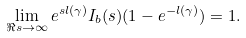Convert formula to latex. <formula><loc_0><loc_0><loc_500><loc_500>\lim _ { \Re s \to \infty } e ^ { s l ( \gamma ) } I _ { b } ( s ) ( 1 - e ^ { - l ( \gamma ) } ) = 1 .</formula> 